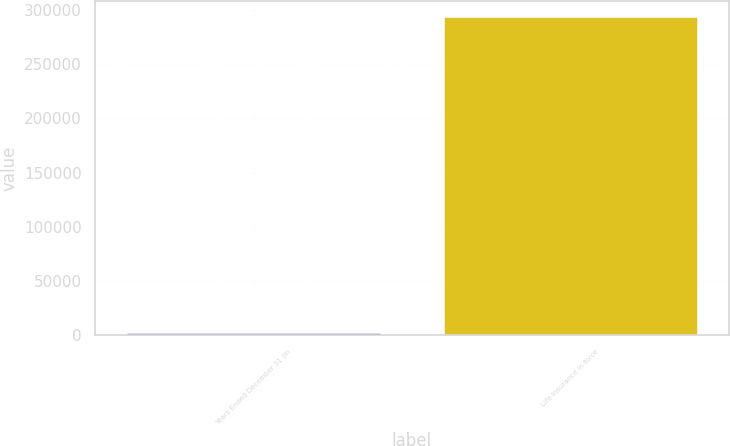Convert chart. <chart><loc_0><loc_0><loc_500><loc_500><bar_chart><fcel>Years Ended December 31 (in<fcel>Life Insurance in force<nl><fcel>2003<fcel>293064<nl></chart> 